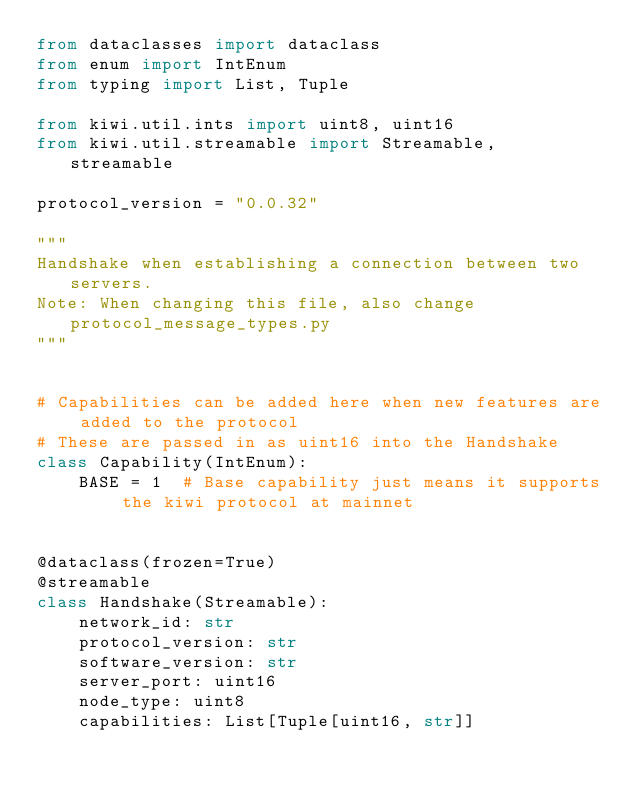<code> <loc_0><loc_0><loc_500><loc_500><_Python_>from dataclasses import dataclass
from enum import IntEnum
from typing import List, Tuple

from kiwi.util.ints import uint8, uint16
from kiwi.util.streamable import Streamable, streamable

protocol_version = "0.0.32"

"""
Handshake when establishing a connection between two servers.
Note: When changing this file, also change protocol_message_types.py
"""


# Capabilities can be added here when new features are added to the protocol
# These are passed in as uint16 into the Handshake
class Capability(IntEnum):
    BASE = 1  # Base capability just means it supports the kiwi protocol at mainnet


@dataclass(frozen=True)
@streamable
class Handshake(Streamable):
    network_id: str
    protocol_version: str
    software_version: str
    server_port: uint16
    node_type: uint8
    capabilities: List[Tuple[uint16, str]]
</code> 